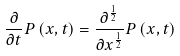Convert formula to latex. <formula><loc_0><loc_0><loc_500><loc_500>\frac { \partial } { \partial t } P \left ( x , t \right ) = \frac { \partial ^ { \frac { 1 } { 2 } } } { \partial x ^ { \frac { 1 } { 2 } } } P \left ( x , t \right )</formula> 